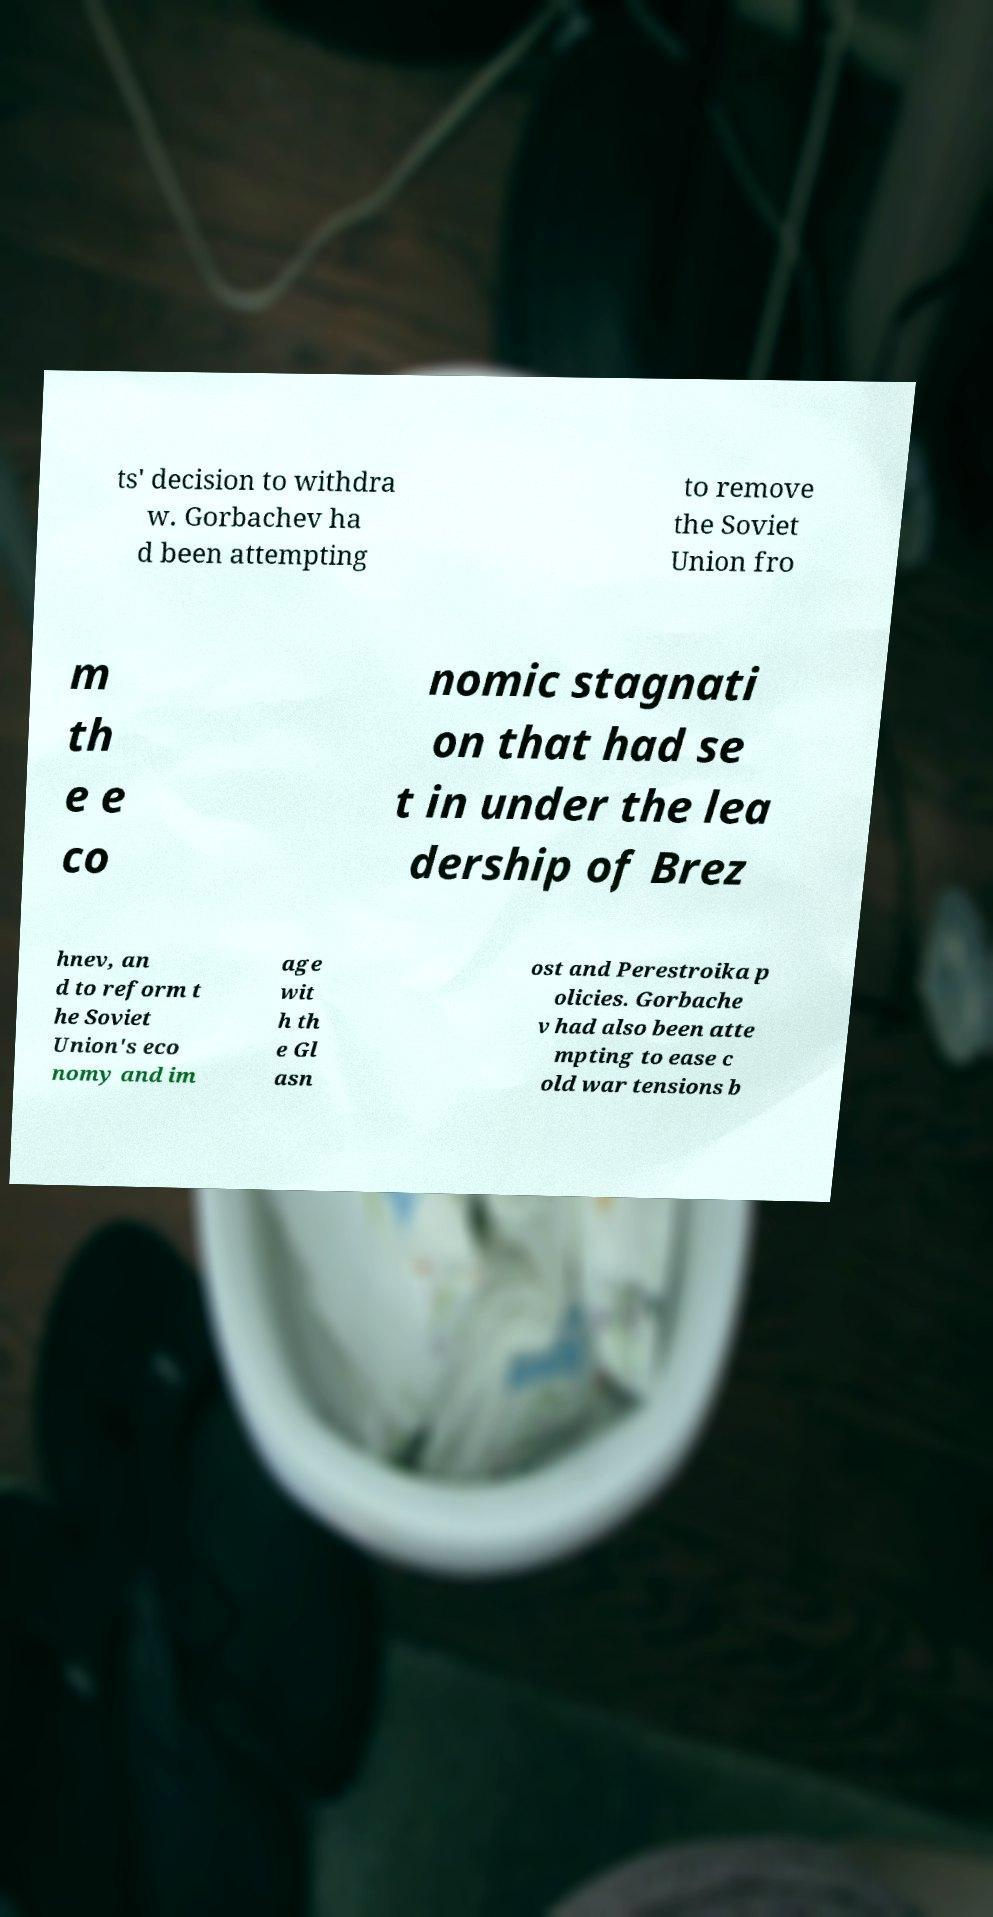What messages or text are displayed in this image? I need them in a readable, typed format. ts' decision to withdra w. Gorbachev ha d been attempting to remove the Soviet Union fro m th e e co nomic stagnati on that had se t in under the lea dership of Brez hnev, an d to reform t he Soviet Union's eco nomy and im age wit h th e Gl asn ost and Perestroika p olicies. Gorbache v had also been atte mpting to ease c old war tensions b 